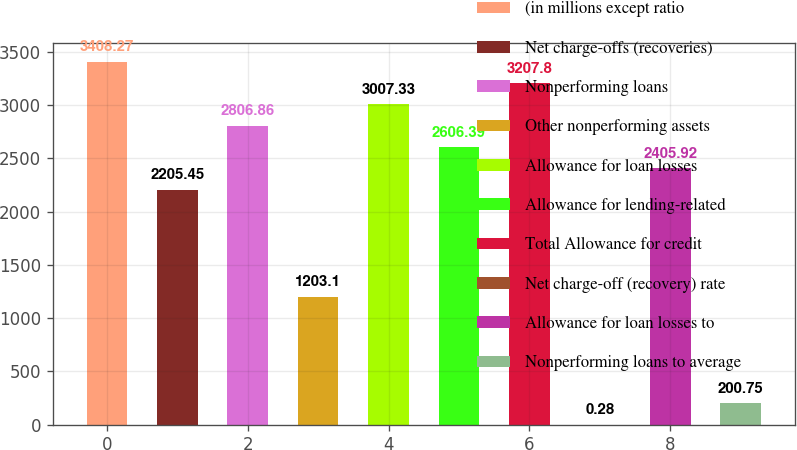Convert chart. <chart><loc_0><loc_0><loc_500><loc_500><bar_chart><fcel>(in millions except ratio<fcel>Net charge-offs (recoveries)<fcel>Nonperforming loans<fcel>Other nonperforming assets<fcel>Allowance for loan losses<fcel>Allowance for lending-related<fcel>Total Allowance for credit<fcel>Net charge-off (recovery) rate<fcel>Allowance for loan losses to<fcel>Nonperforming loans to average<nl><fcel>3408.27<fcel>2205.45<fcel>2806.86<fcel>1203.1<fcel>3007.33<fcel>2606.39<fcel>3207.8<fcel>0.28<fcel>2405.92<fcel>200.75<nl></chart> 